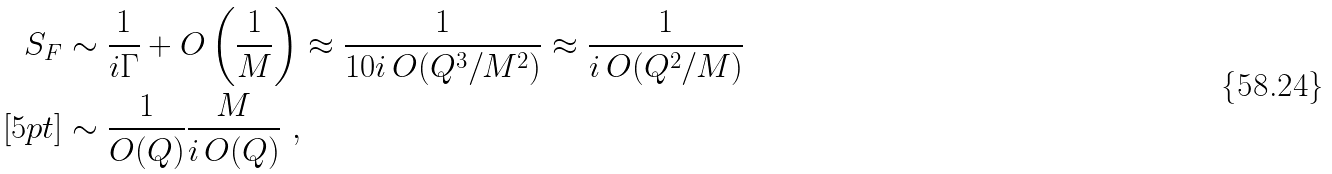<formula> <loc_0><loc_0><loc_500><loc_500>S _ { F } & \sim \frac { 1 } { i \Gamma } + O \left ( \frac { 1 } { M } \right ) \approx \frac { 1 } { 1 0 i \, O ( Q ^ { 3 } / M ^ { 2 } ) } \approx \frac { 1 } { i \, O ( Q ^ { 2 } / M ) } \\ [ 5 p t ] & \sim \frac { 1 } { O ( Q ) } \frac { M } { i \, O ( Q ) } \ ,</formula> 